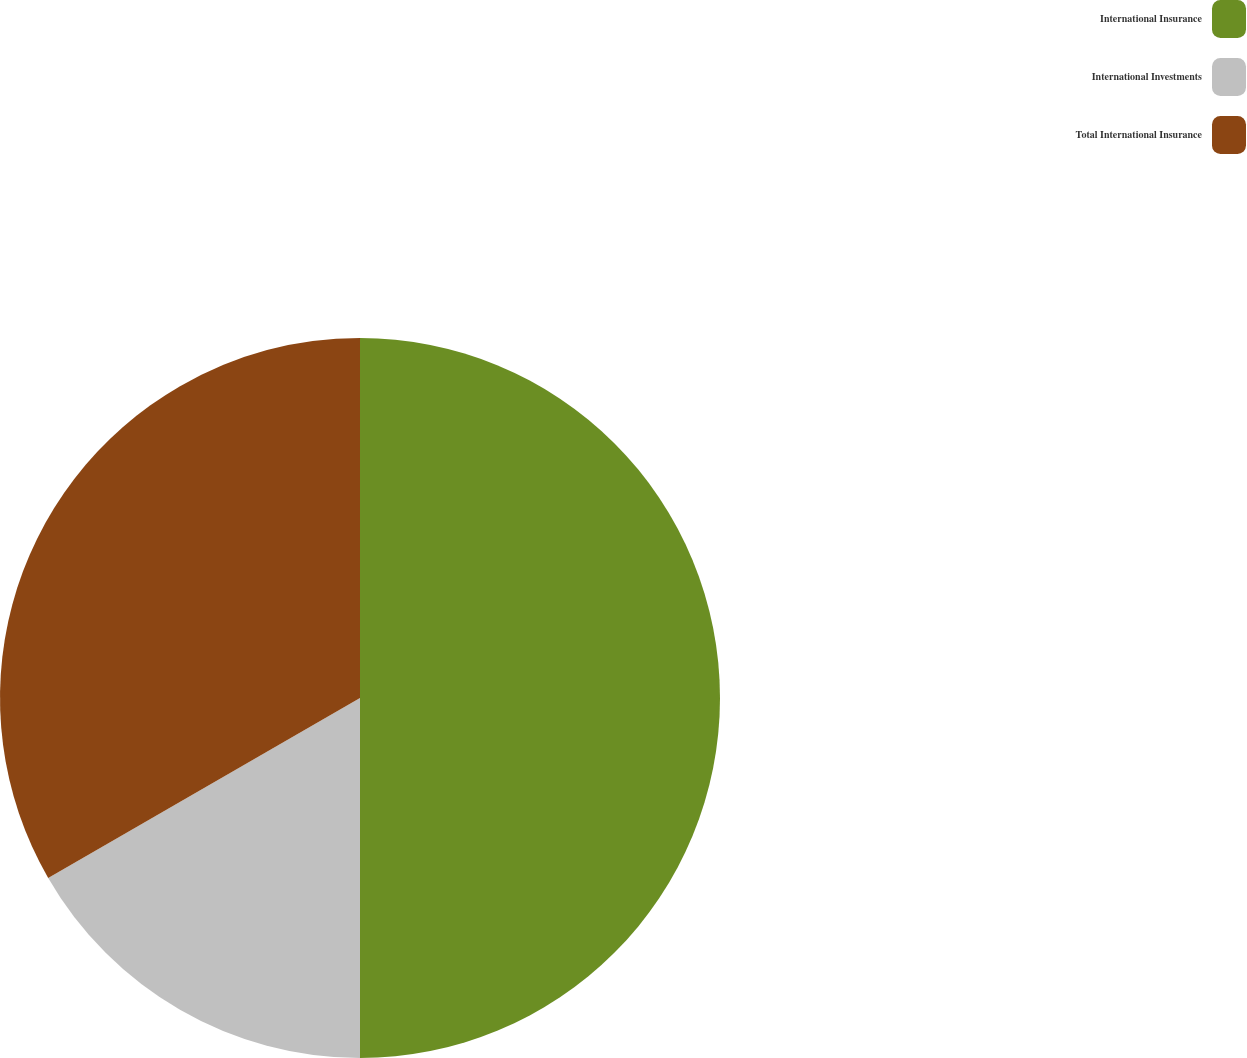<chart> <loc_0><loc_0><loc_500><loc_500><pie_chart><fcel>International Insurance<fcel>International Investments<fcel>Total International Insurance<nl><fcel>50.0%<fcel>16.67%<fcel>33.33%<nl></chart> 